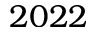<formula> <loc_0><loc_0><loc_500><loc_500>2 0 2 2</formula> 